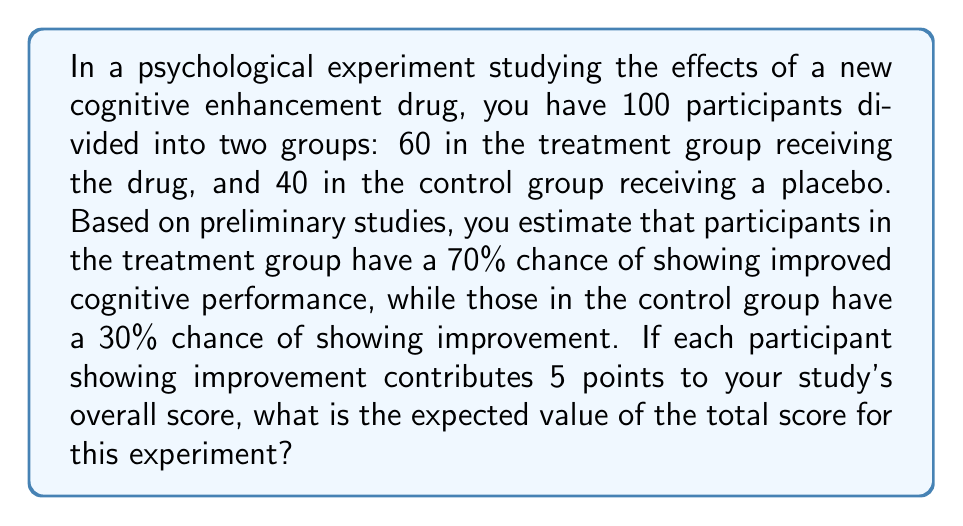Teach me how to tackle this problem. Let's approach this step-by-step:

1) First, let's calculate the expected number of participants showing improvement in each group:

   Treatment group: 
   $$ E(T) = 60 \times 0.70 = 42 $$

   Control group:
   $$ E(C) = 40 \times 0.30 = 12 $$

2) Now, let's add these together to get the total expected number of participants showing improvement:

   $$ E(Total) = E(T) + E(C) = 42 + 12 = 54 $$

3) Each participant showing improvement contributes 5 points to the overall score. So, we multiply the expected number of participants showing improvement by 5:

   $$ E(Score) = E(Total) \times 5 = 54 \times 5 = 270 $$

Therefore, the expected value of the total score for this experiment is 270 points.
Answer: 270 points 